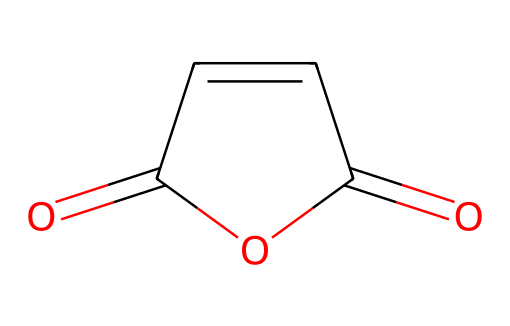What is the molecular formula of maleic anhydride? To determine the molecular formula, count the carbon (C), hydrogen (H), and oxygen (O) atoms in the SMILES representation. The structure shows 4 carbon atoms, 2 hydrogen atoms, and 3 oxygen atoms. Thus, the molecular formula is C4H2O3.
Answer: C4H2O3 How many double bonds are present in maleic anhydride? In the SMILES representation, observe the bonds between carbon and the overall structure. The structure includes two C=C double bonds and two C=O double bonds (in the carbonyl groups), making a total of four double bonds.
Answer: 4 What type of functional groups are present in maleic anhydride? Analyzing the chemical structure, it shows the presence of an anhydride and two carbonyl (C=O) groups. An anhydride is characterized by two acyl groups bonded through an oxygen atom.
Answer: anhydride, carbonyl How many rings are in the structure of maleic anhydride? By inspecting the SMILES notation, identify any ring structures. The "C1" indicates the start of a ring, which closes back after traversing the atoms, confirming there is one ring in the structure.
Answer: 1 Is maleic anhydride polar or nonpolar? To determine polarity, consider the electronegativity difference and the presence of polar functional groups like the carbonyl. The presence of multiple polar C=O bonds and the anhydride nature indicates the molecule is polar overall.
Answer: polar What is the significance of maleic anhydride in making paints? Maleic anhydride is utilized in paint formulations due to its reactivity and ability to improve adhesion and durability of the paint. Its structure allows for the formation of stable bonds, making it suitable for non-toxic children's crafts.
Answer: improves adhesion and durability 